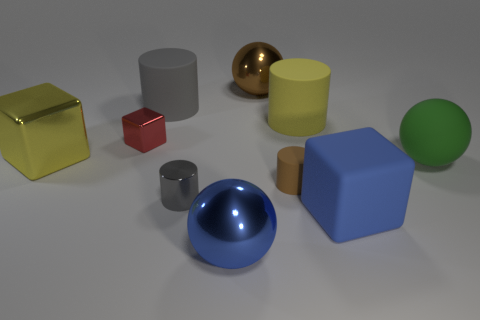Is the color of the rubber cube the same as the tiny rubber thing?
Ensure brevity in your answer.  No. There is a large ball that is behind the rubber object left of the large brown object; what color is it?
Provide a succinct answer. Brown. The brown thing that is the same material as the green thing is what size?
Offer a terse response. Small. How many tiny brown rubber objects have the same shape as the yellow rubber object?
Give a very brief answer. 1. How many objects are shiny spheres that are in front of the brown matte object or big blue things that are on the left side of the blue cube?
Make the answer very short. 1. How many large rubber cubes are left of the big blue object that is on the right side of the big blue shiny object?
Provide a succinct answer. 0. There is a small gray thing that is to the left of the large blue metallic object; is it the same shape as the gray object that is behind the tiny red metallic object?
Keep it short and to the point. Yes. What shape is the big thing that is the same color as the small rubber thing?
Offer a terse response. Sphere. Is there a yellow object made of the same material as the small red object?
Your response must be concise. Yes. How many metallic things are either small blocks or tiny gray spheres?
Make the answer very short. 1. 